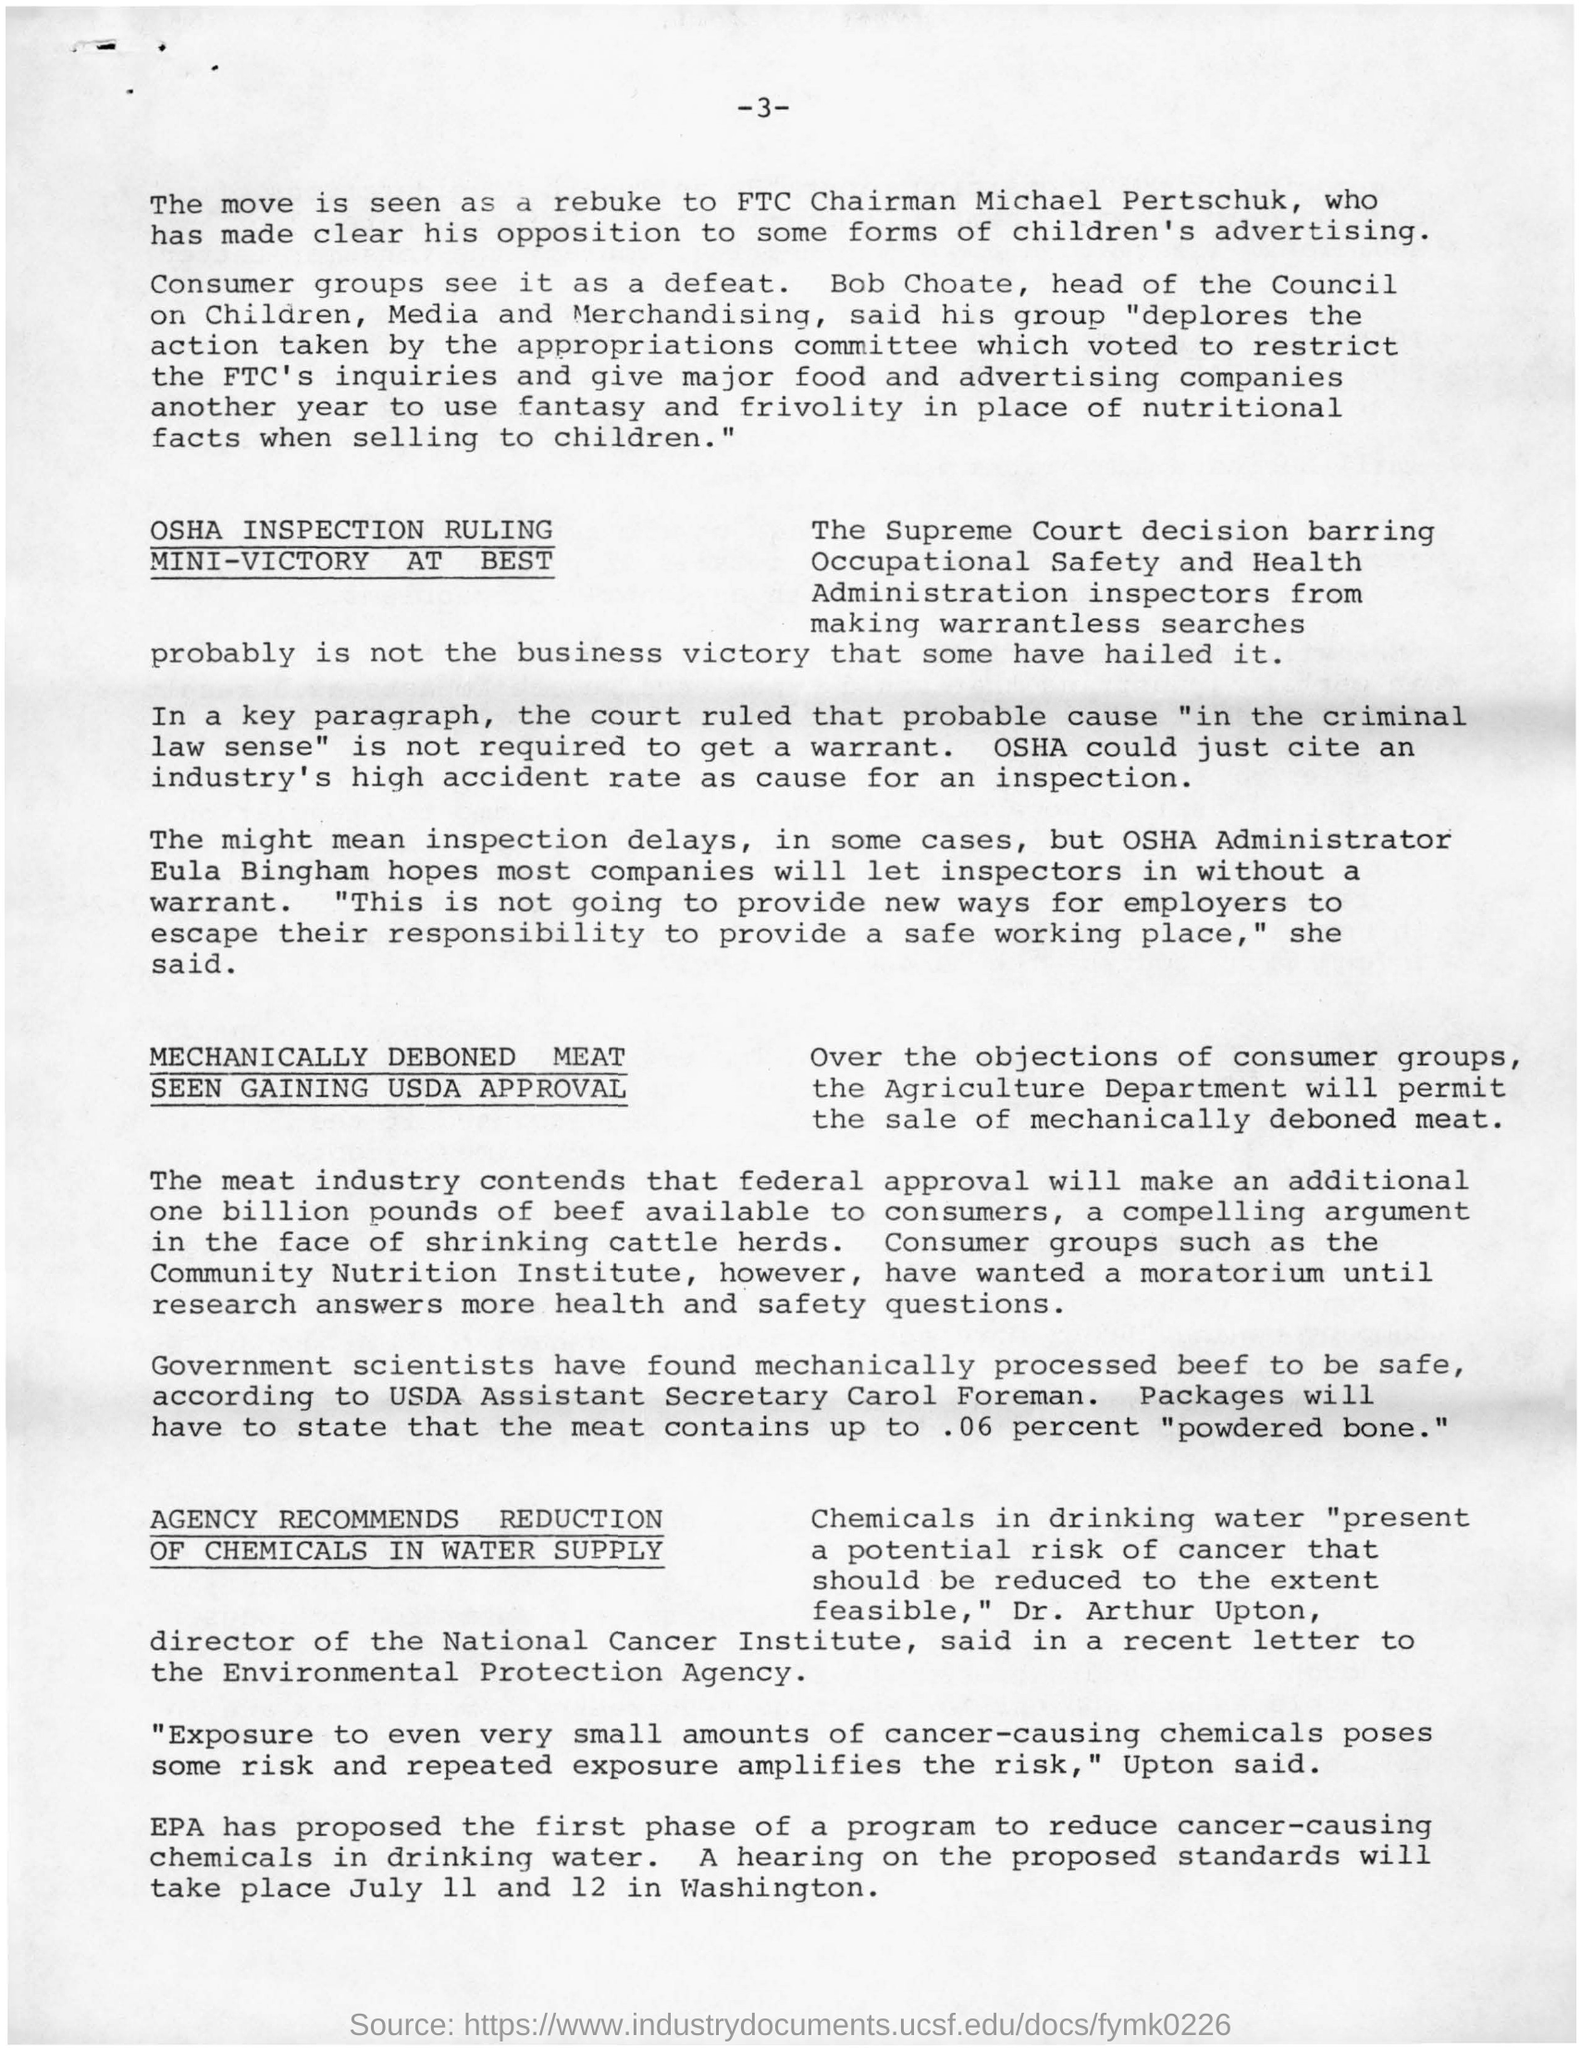Which groups see it as a defeat?
Your response must be concise. Consumer groups. Who was the head of the council?
Your answer should be very brief. Bob Choate. What was present in the drinking water?
Keep it short and to the point. CHEMICALS. Who said chemicals should be reduced to extent feasible?
Offer a very short reply. DR. ARTHUR UPTON. 